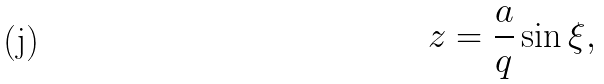<formula> <loc_0><loc_0><loc_500><loc_500>z = \frac { a } { q } \sin \xi ,</formula> 